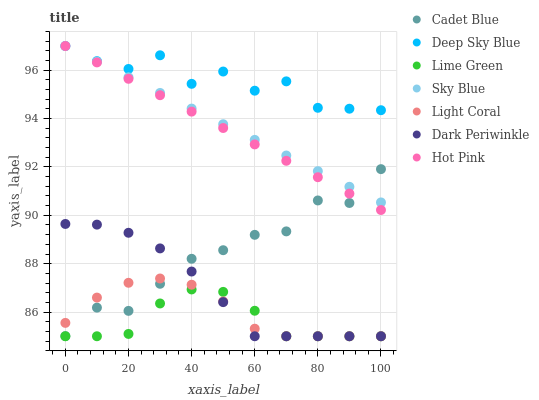Does Lime Green have the minimum area under the curve?
Answer yes or no. Yes. Does Deep Sky Blue have the maximum area under the curve?
Answer yes or no. Yes. Does Hot Pink have the minimum area under the curve?
Answer yes or no. No. Does Hot Pink have the maximum area under the curve?
Answer yes or no. No. Is Sky Blue the smoothest?
Answer yes or no. Yes. Is Deep Sky Blue the roughest?
Answer yes or no. Yes. Is Hot Pink the smoothest?
Answer yes or no. No. Is Hot Pink the roughest?
Answer yes or no. No. Does Light Coral have the lowest value?
Answer yes or no. Yes. Does Hot Pink have the lowest value?
Answer yes or no. No. Does Sky Blue have the highest value?
Answer yes or no. Yes. Does Light Coral have the highest value?
Answer yes or no. No. Is Lime Green less than Hot Pink?
Answer yes or no. Yes. Is Cadet Blue greater than Lime Green?
Answer yes or no. Yes. Does Light Coral intersect Dark Periwinkle?
Answer yes or no. Yes. Is Light Coral less than Dark Periwinkle?
Answer yes or no. No. Is Light Coral greater than Dark Periwinkle?
Answer yes or no. No. Does Lime Green intersect Hot Pink?
Answer yes or no. No. 